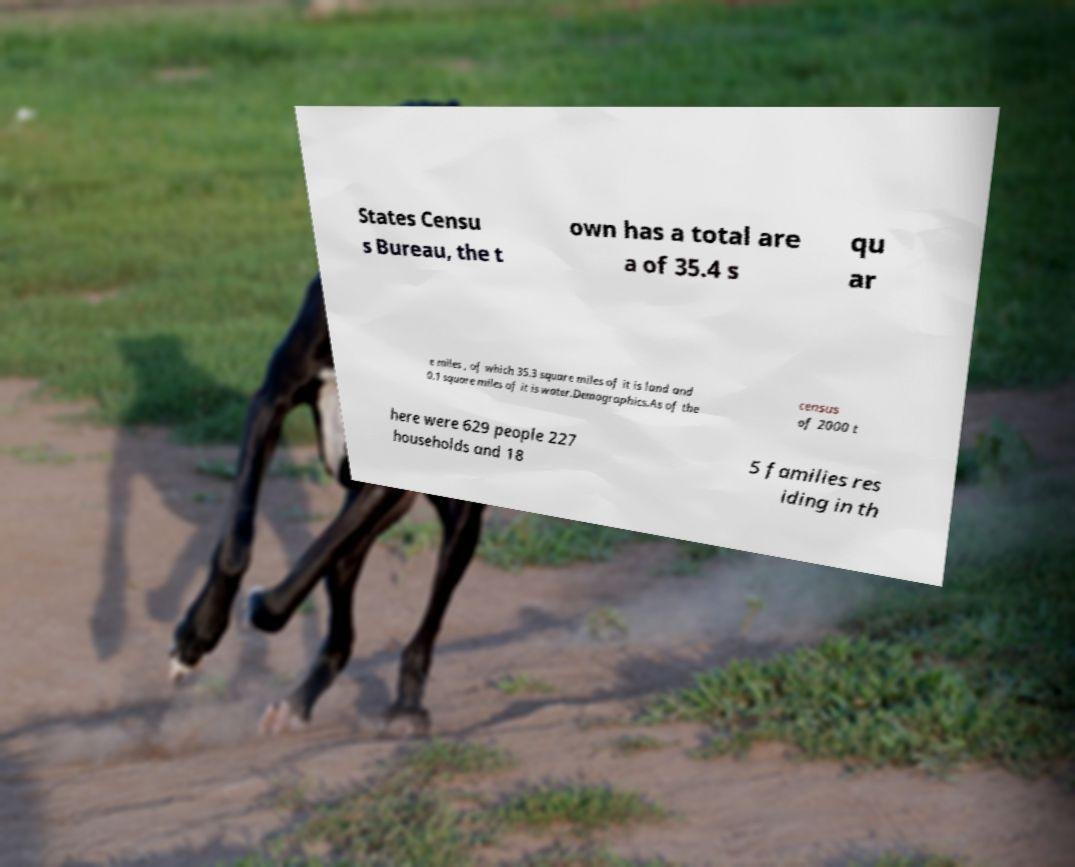Can you accurately transcribe the text from the provided image for me? States Censu s Bureau, the t own has a total are a of 35.4 s qu ar e miles , of which 35.3 square miles of it is land and 0.1 square miles of it is water.Demographics.As of the census of 2000 t here were 629 people 227 households and 18 5 families res iding in th 